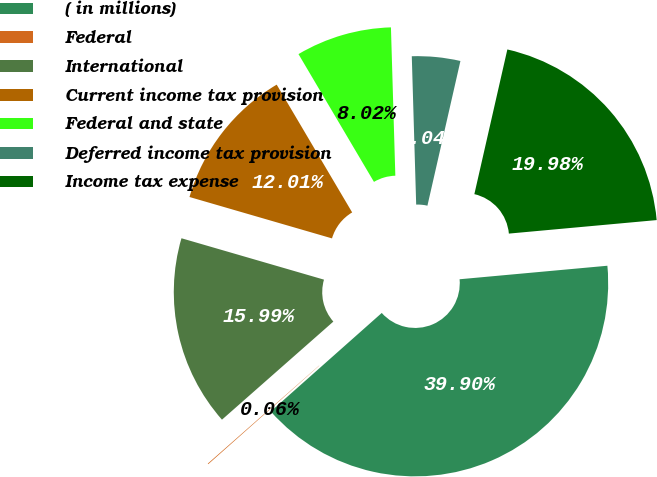Convert chart. <chart><loc_0><loc_0><loc_500><loc_500><pie_chart><fcel>( in millions)<fcel>Federal<fcel>International<fcel>Current income tax provision<fcel>Federal and state<fcel>Deferred income tax provision<fcel>Income tax expense<nl><fcel>39.9%<fcel>0.06%<fcel>15.99%<fcel>12.01%<fcel>8.02%<fcel>4.04%<fcel>19.98%<nl></chart> 